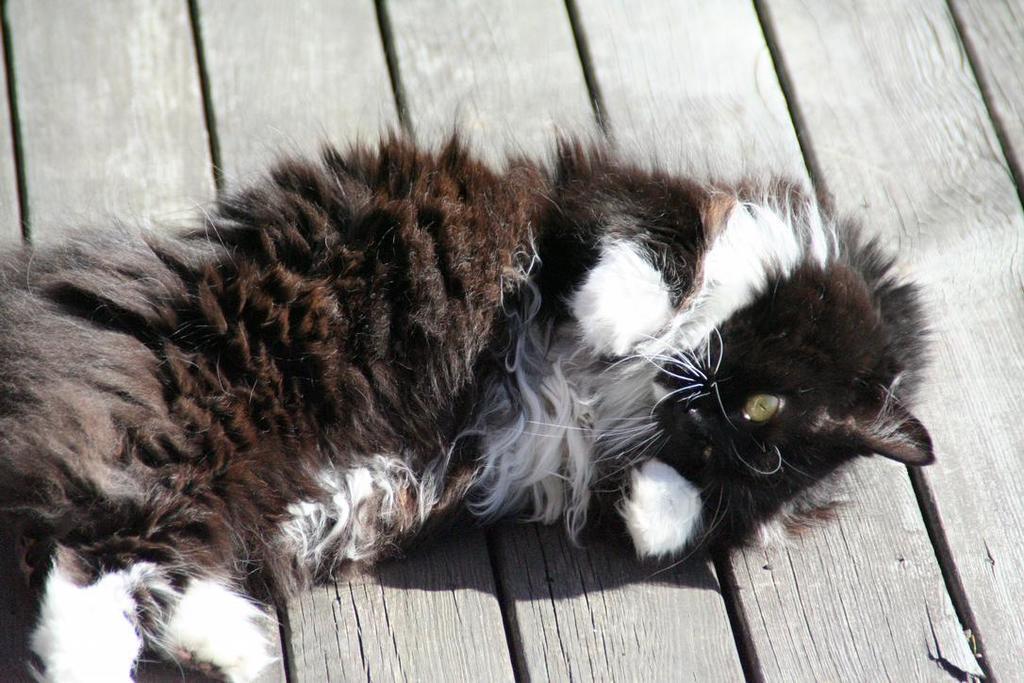Can you describe this image briefly? Here in this picture we can see a cat laying on wooden floor present over there. 